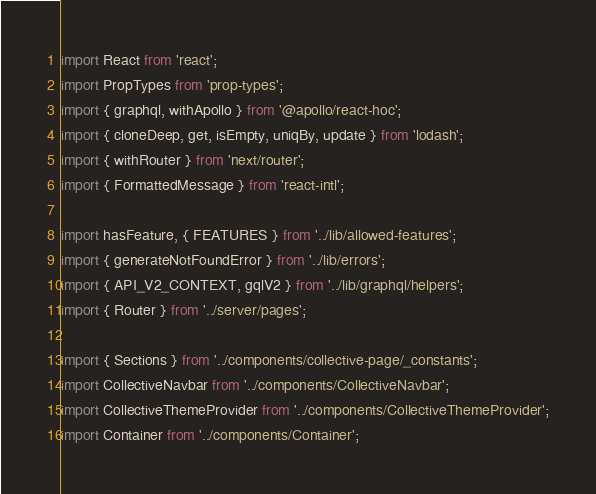<code> <loc_0><loc_0><loc_500><loc_500><_JavaScript_>import React from 'react';
import PropTypes from 'prop-types';
import { graphql, withApollo } from '@apollo/react-hoc';
import { cloneDeep, get, isEmpty, uniqBy, update } from 'lodash';
import { withRouter } from 'next/router';
import { FormattedMessage } from 'react-intl';

import hasFeature, { FEATURES } from '../lib/allowed-features';
import { generateNotFoundError } from '../lib/errors';
import { API_V2_CONTEXT, gqlV2 } from '../lib/graphql/helpers';
import { Router } from '../server/pages';

import { Sections } from '../components/collective-page/_constants';
import CollectiveNavbar from '../components/CollectiveNavbar';
import CollectiveThemeProvider from '../components/CollectiveThemeProvider';
import Container from '../components/Container';</code> 